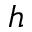Convert formula to latex. <formula><loc_0><loc_0><loc_500><loc_500>h</formula> 